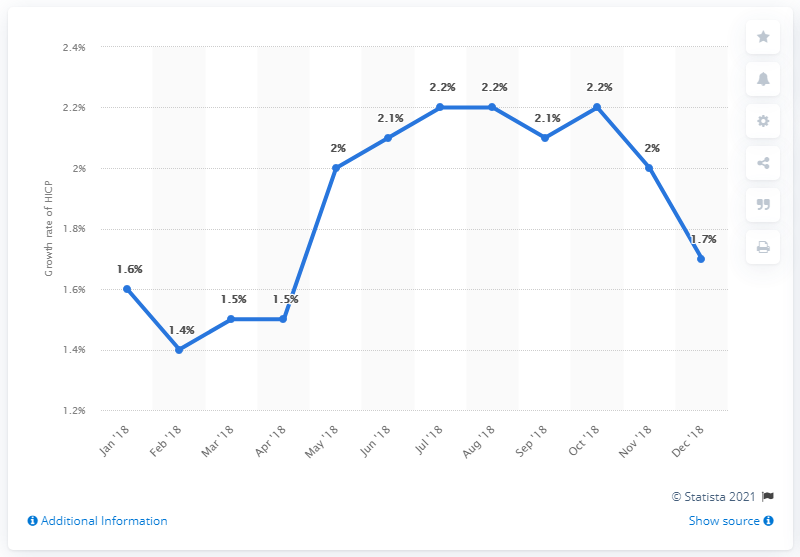Highlight a few significant elements in this photo. The inflation rate in December 2018 was 1.7%. 